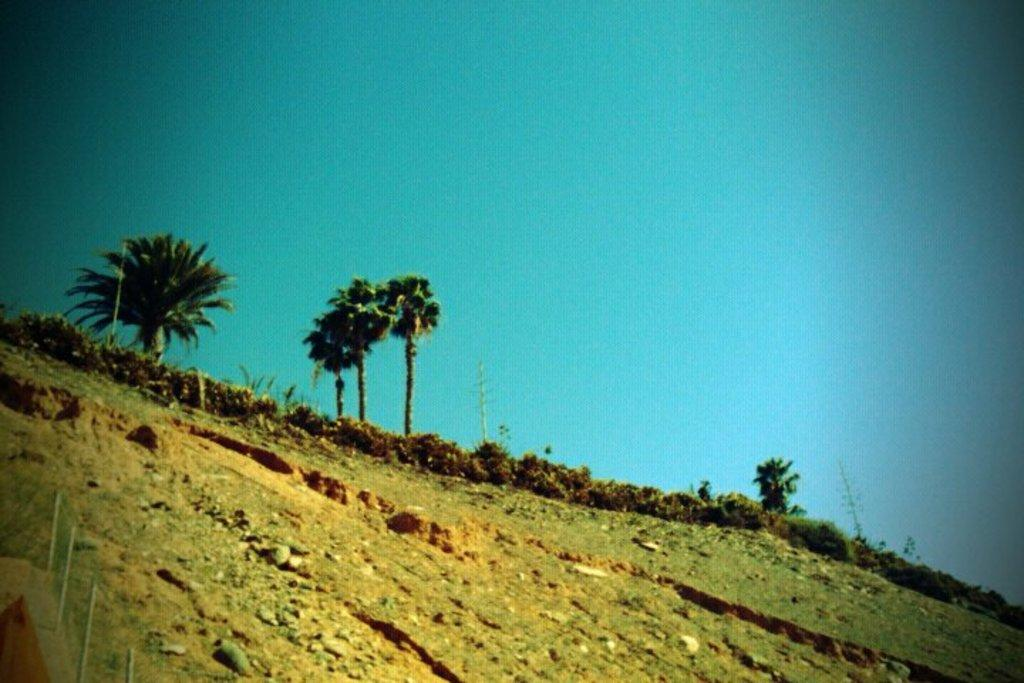What type of natural elements can be seen in the image? There are rocks, plants, and trees in the image. Can you describe the plants in the image? The image contains plants, but the specific type of plants cannot be determined from the provided facts. What is the primary difference between the rocks and the plants in the image? The rocks are inanimate objects, while the plants are living organisms. What type of balloon is floating above the trees in the image? There is no balloon present in the image; it only contains rocks, plants, and trees. 